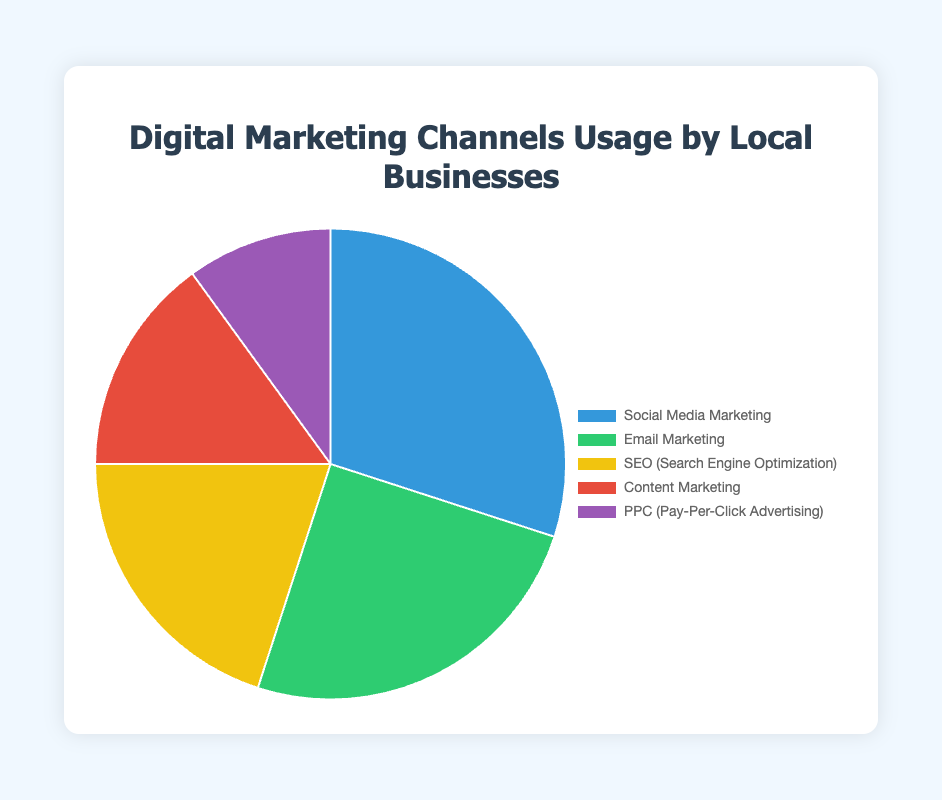What's the largest single channel usage percentage? Look at the pie chart and find the slice with the largest percentage.
Answer: Social Media Marketing with 30% What's the combined percentage of Social Media Marketing and Email Marketing? Add the percentages of Social Media Marketing (30%) and Email Marketing (25%). 30 + 25 = 55%
Answer: 55% What is the sum of the percentages of the three least used channels? Add the percentages of the three channels with the smallest values: SEO (20%), Content Marketing (15%), and PPC (10%). 20 + 15 + 10 = 45%
Answer: 45% Which channel has a greater usage percentage: SEO or Content Marketing? Compare the percentages of SEO (20%) and Content Marketing (15%).
Answer: SEO How much more popular is Social Media Marketing compared to PPC? Subtract the percentage of PPC (10%) from the percentage of Social Media Marketing (30%). 30 - 10 = 20%
Answer: 20% What is the average percentage of all the channels? Add the percentages of all channels and then divide by the number of channels: (30 + 25 + 20 + 15 + 10) / 5 = 100 / 5 = 20%
Answer: 20% List the channels in order of usage from highest to lowest. Arrange the channels based on their percentages from the largest to the smallest: Social Media Marketing (30%), Email Marketing (25%), SEO (20%), Content Marketing (15%), PPC (10%).
Answer: Social Media Marketing, Email Marketing, SEO, Content Marketing, PPC Which color represents the Content Marketing slice? Look for the color in the pie chart associated with Content Marketing.
Answer: Red What's the difference in usage percentage between the most used and least used channels? Subtract the percentage of the least used channel (PPC with 10%) from the most used channel (Social Media Marketing with 30%). 30 - 10 = 20%
Answer: 20% How does the usage percentage of Email Marketing compare to SEO and Content Marketing combined? Add the percentages of SEO (20%) and Content Marketing (15%), then compare to Email Marketing (25%). 20 + 15 = 35% which is greater than 25%.
Answer: Less 